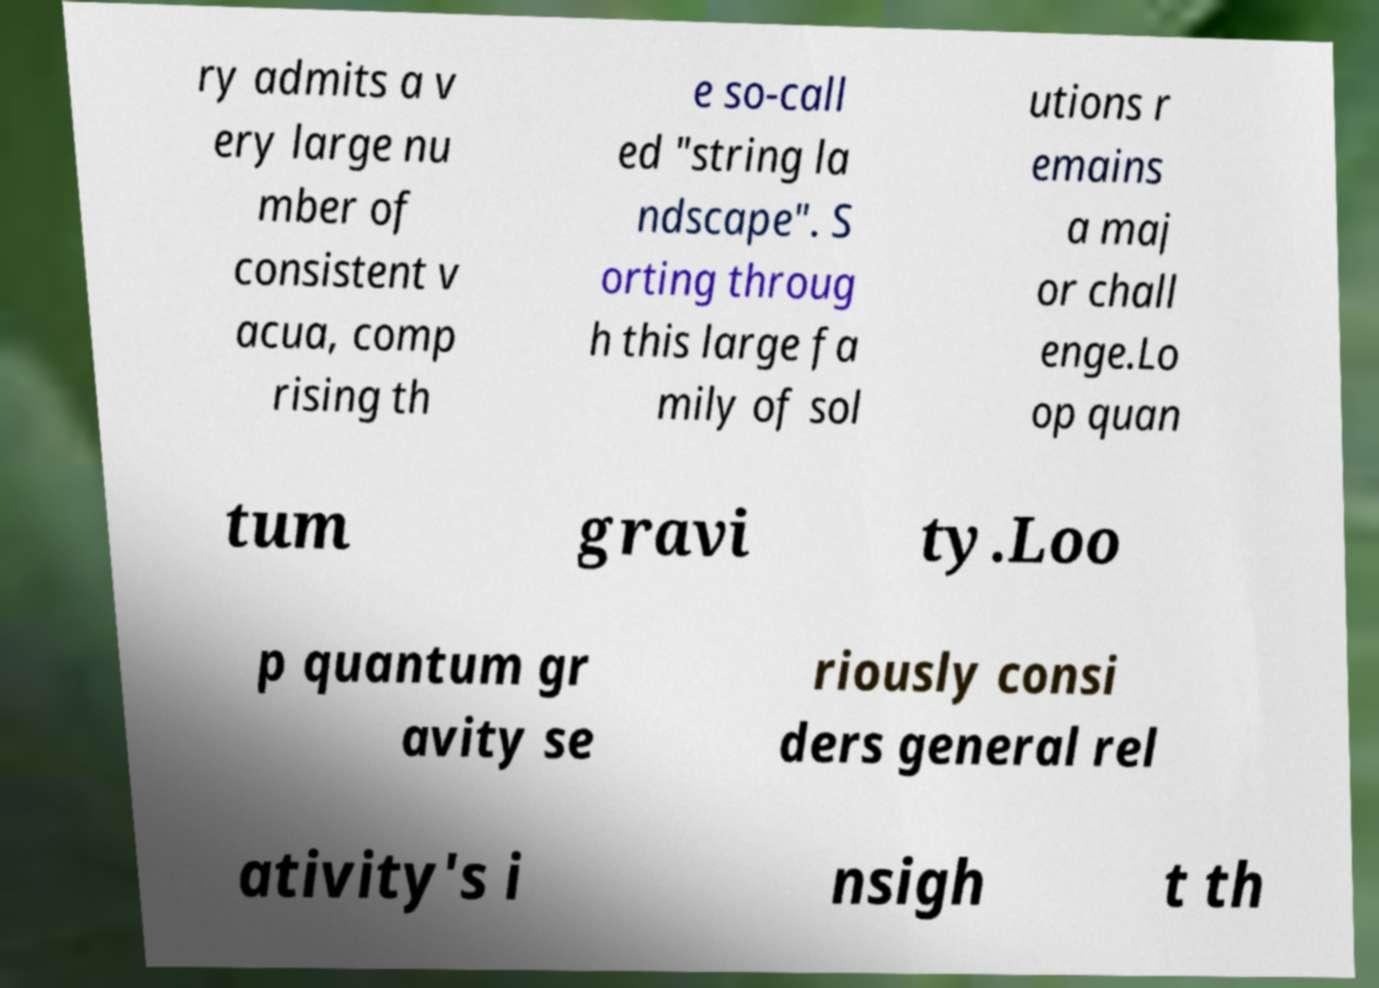Can you read and provide the text displayed in the image?This photo seems to have some interesting text. Can you extract and type it out for me? ry admits a v ery large nu mber of consistent v acua, comp rising th e so-call ed "string la ndscape". S orting throug h this large fa mily of sol utions r emains a maj or chall enge.Lo op quan tum gravi ty.Loo p quantum gr avity se riously consi ders general rel ativity's i nsigh t th 